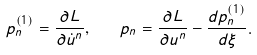Convert formula to latex. <formula><loc_0><loc_0><loc_500><loc_500>p ^ { ( 1 ) } _ { n } = \frac { \partial L } { \partial \dot { u } ^ { n } } , \quad p _ { n } = \frac { \partial L } { \partial u ^ { n } } - \frac { d p ^ { ( 1 ) } _ { n } } { d \xi } .</formula> 